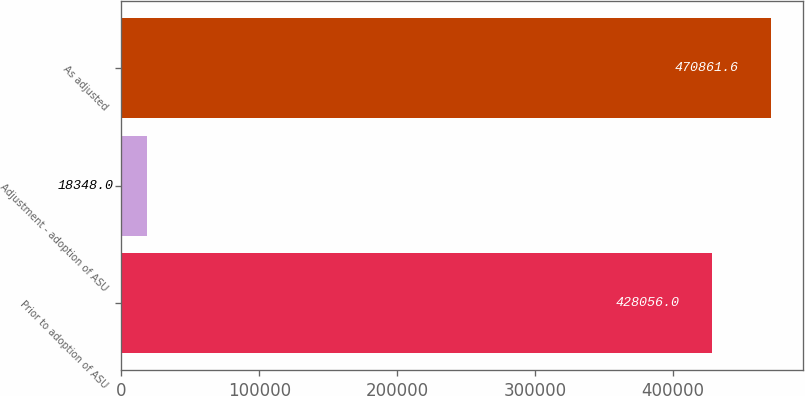Convert chart. <chart><loc_0><loc_0><loc_500><loc_500><bar_chart><fcel>Prior to adoption of ASU<fcel>Adjustment - adoption of ASU<fcel>As adjusted<nl><fcel>428056<fcel>18348<fcel>470862<nl></chart> 